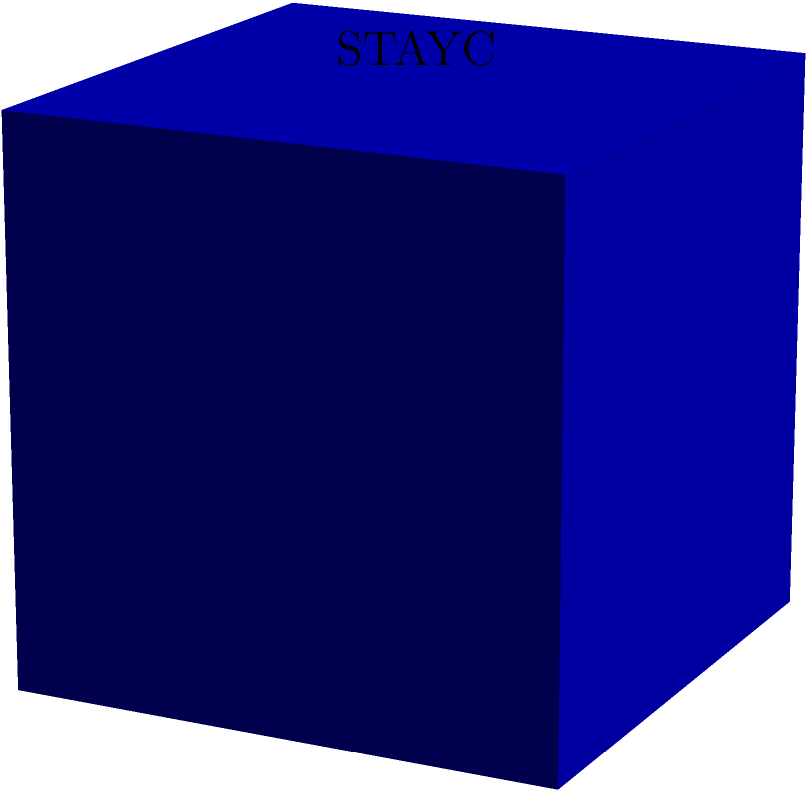STAYC's latest album comes in a cube-shaped package with each side measuring 10 cm. If the group decides to create a special edition by covering the entire surface of the package with holographic stickers, what is the total surface area they need to cover? To find the surface area of a cube, we need to follow these steps:

1. Identify the length of one side of the cube:
   In this case, each side measures 10 cm.

2. Calculate the area of one face of the cube:
   Area of one face = side length × side length
   $A = 10 \text{ cm} \times 10 \text{ cm} = 100 \text{ cm}^2$

3. Determine the number of faces on a cube:
   A cube has 6 faces.

4. Calculate the total surface area by multiplying the area of one face by the number of faces:
   Total surface area = Area of one face × Number of faces
   $SA = 100 \text{ cm}^2 \times 6 = 600 \text{ cm}^2$

Therefore, STAYC needs to cover a total surface area of 600 square centimeters with holographic stickers for their special edition album package.
Answer: 600 cm² 